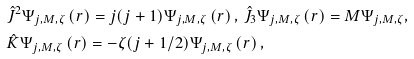<formula> <loc_0><loc_0><loc_500><loc_500>& \hat { J } ^ { 2 } \Psi _ { j , M , \zeta } \left ( r \right ) = j ( j + 1 ) \Psi _ { j , M , \zeta } \left ( r \right ) , \, \hat { J } _ { 3 } \Psi _ { j , M , \zeta } \left ( r \right ) = M \Psi _ { j , M , \zeta } , \\ & \hat { K } \Psi _ { j , M , \zeta } \left ( r \right ) = - \zeta ( j + 1 / 2 ) \Psi _ { j , M , \zeta } \left ( r \right ) ,</formula> 